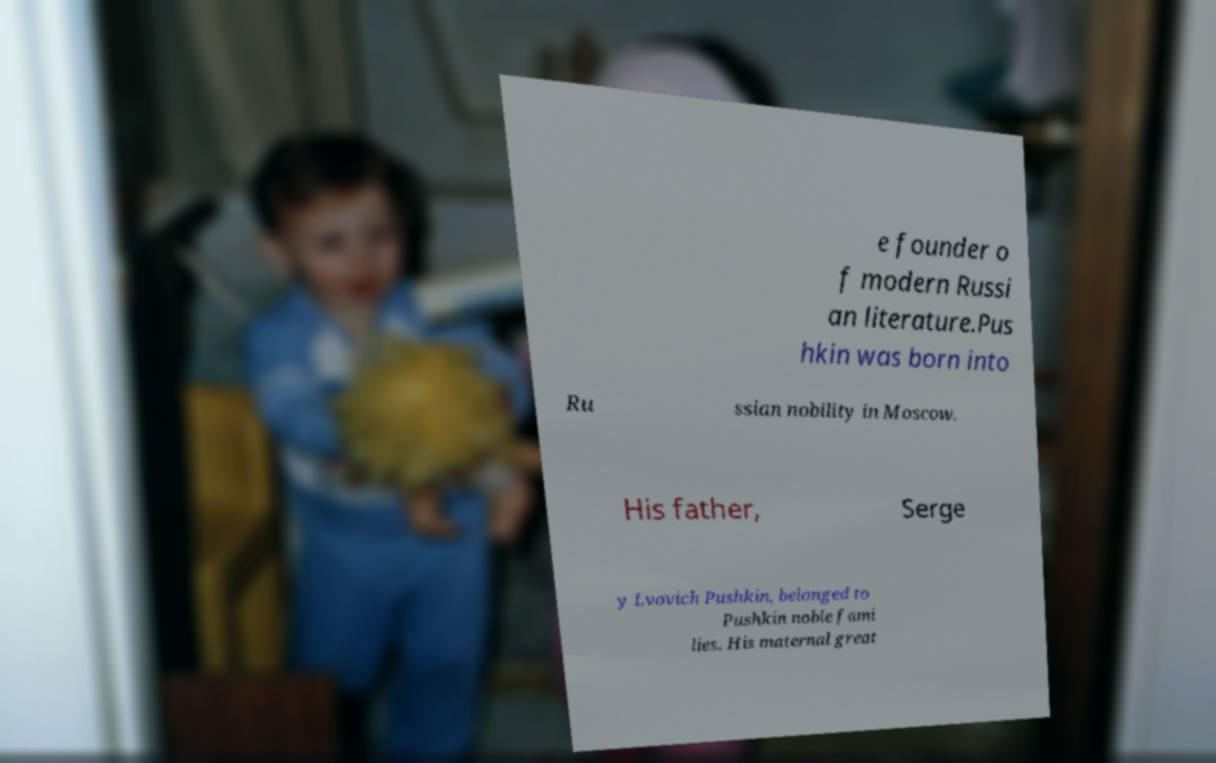Could you extract and type out the text from this image? e founder o f modern Russi an literature.Pus hkin was born into Ru ssian nobility in Moscow. His father, Serge y Lvovich Pushkin, belonged to Pushkin noble fami lies. His maternal great 